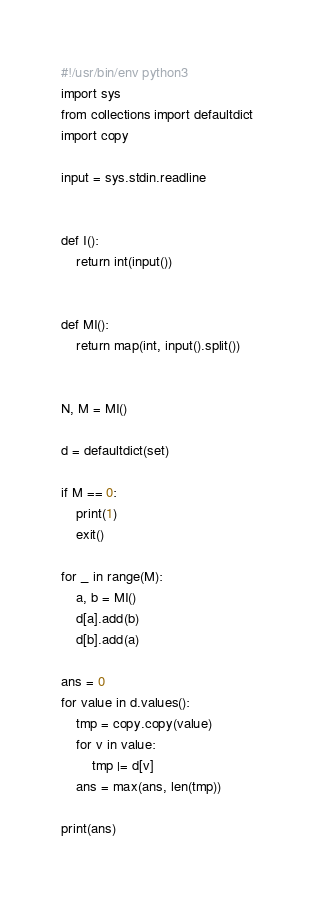Convert code to text. <code><loc_0><loc_0><loc_500><loc_500><_Python_>#!/usr/bin/env python3
import sys
from collections import defaultdict
import copy

input = sys.stdin.readline


def I():
    return int(input())


def MI():
    return map(int, input().split())


N, M = MI()

d = defaultdict(set)

if M == 0:
    print(1)
    exit()

for _ in range(M):
    a, b = MI()
    d[a].add(b)
    d[b].add(a)

ans = 0
for value in d.values():
    tmp = copy.copy(value)
    for v in value:
        tmp |= d[v]
    ans = max(ans, len(tmp))

print(ans)
</code> 